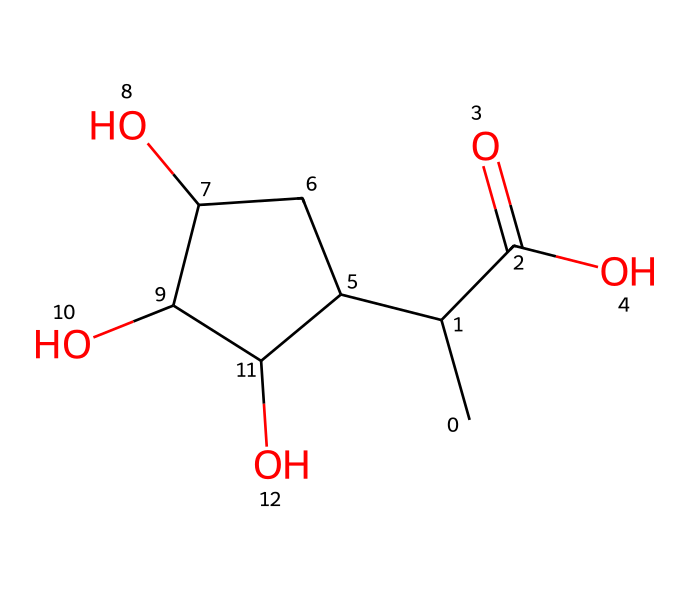What is the main functional group present in this chemical? The provided SMILES shows a carboxylic acid functional group (indicated by "C(=O)O"), which is characterized by a carbon atom double-bonded to an oxygen atom and single-bonded to a hydroxyl group (OH).
Answer: carboxylic acid How many hydroxyl (OH) groups are present in this chemical structure? By analyzing the structure, we can identify two hydroxyl (OH) groups indicated by "C(O)" in the cyclic portion of the molecule, showing two alcohol functionalities.
Answer: two What is the total number of carbon atoms in this chemical? The SMILES structure can be decoded to count the carbon ("C") entries. There are five carbon atoms shown in the linear part and one carbon atom in the ring, totaling six.
Answer: six Does this chemical contain any rings in its structure? The presence of the ring is evident from "C1", which signifies the start of a cyclic structure and suggests at least one ring is present in the molecule.
Answer: yes What type of polymer could this chemical represent in children's outdoor toys? Given the biodegradable nature suggested by the presence of hydroxyl and carboxylic acid groups, this structure implies it may be used in eco-friendly, biodegradable polymers used for children’s outdoor toys.
Answer: biodegradable polymer How many oxygen atoms are in this chemical? Counting the oxygen atoms in the structure, there are three oxygen atoms present; two are in the hydroxyl (OH) groups and one in the carboxylic acid (C(=O)O).
Answer: three 